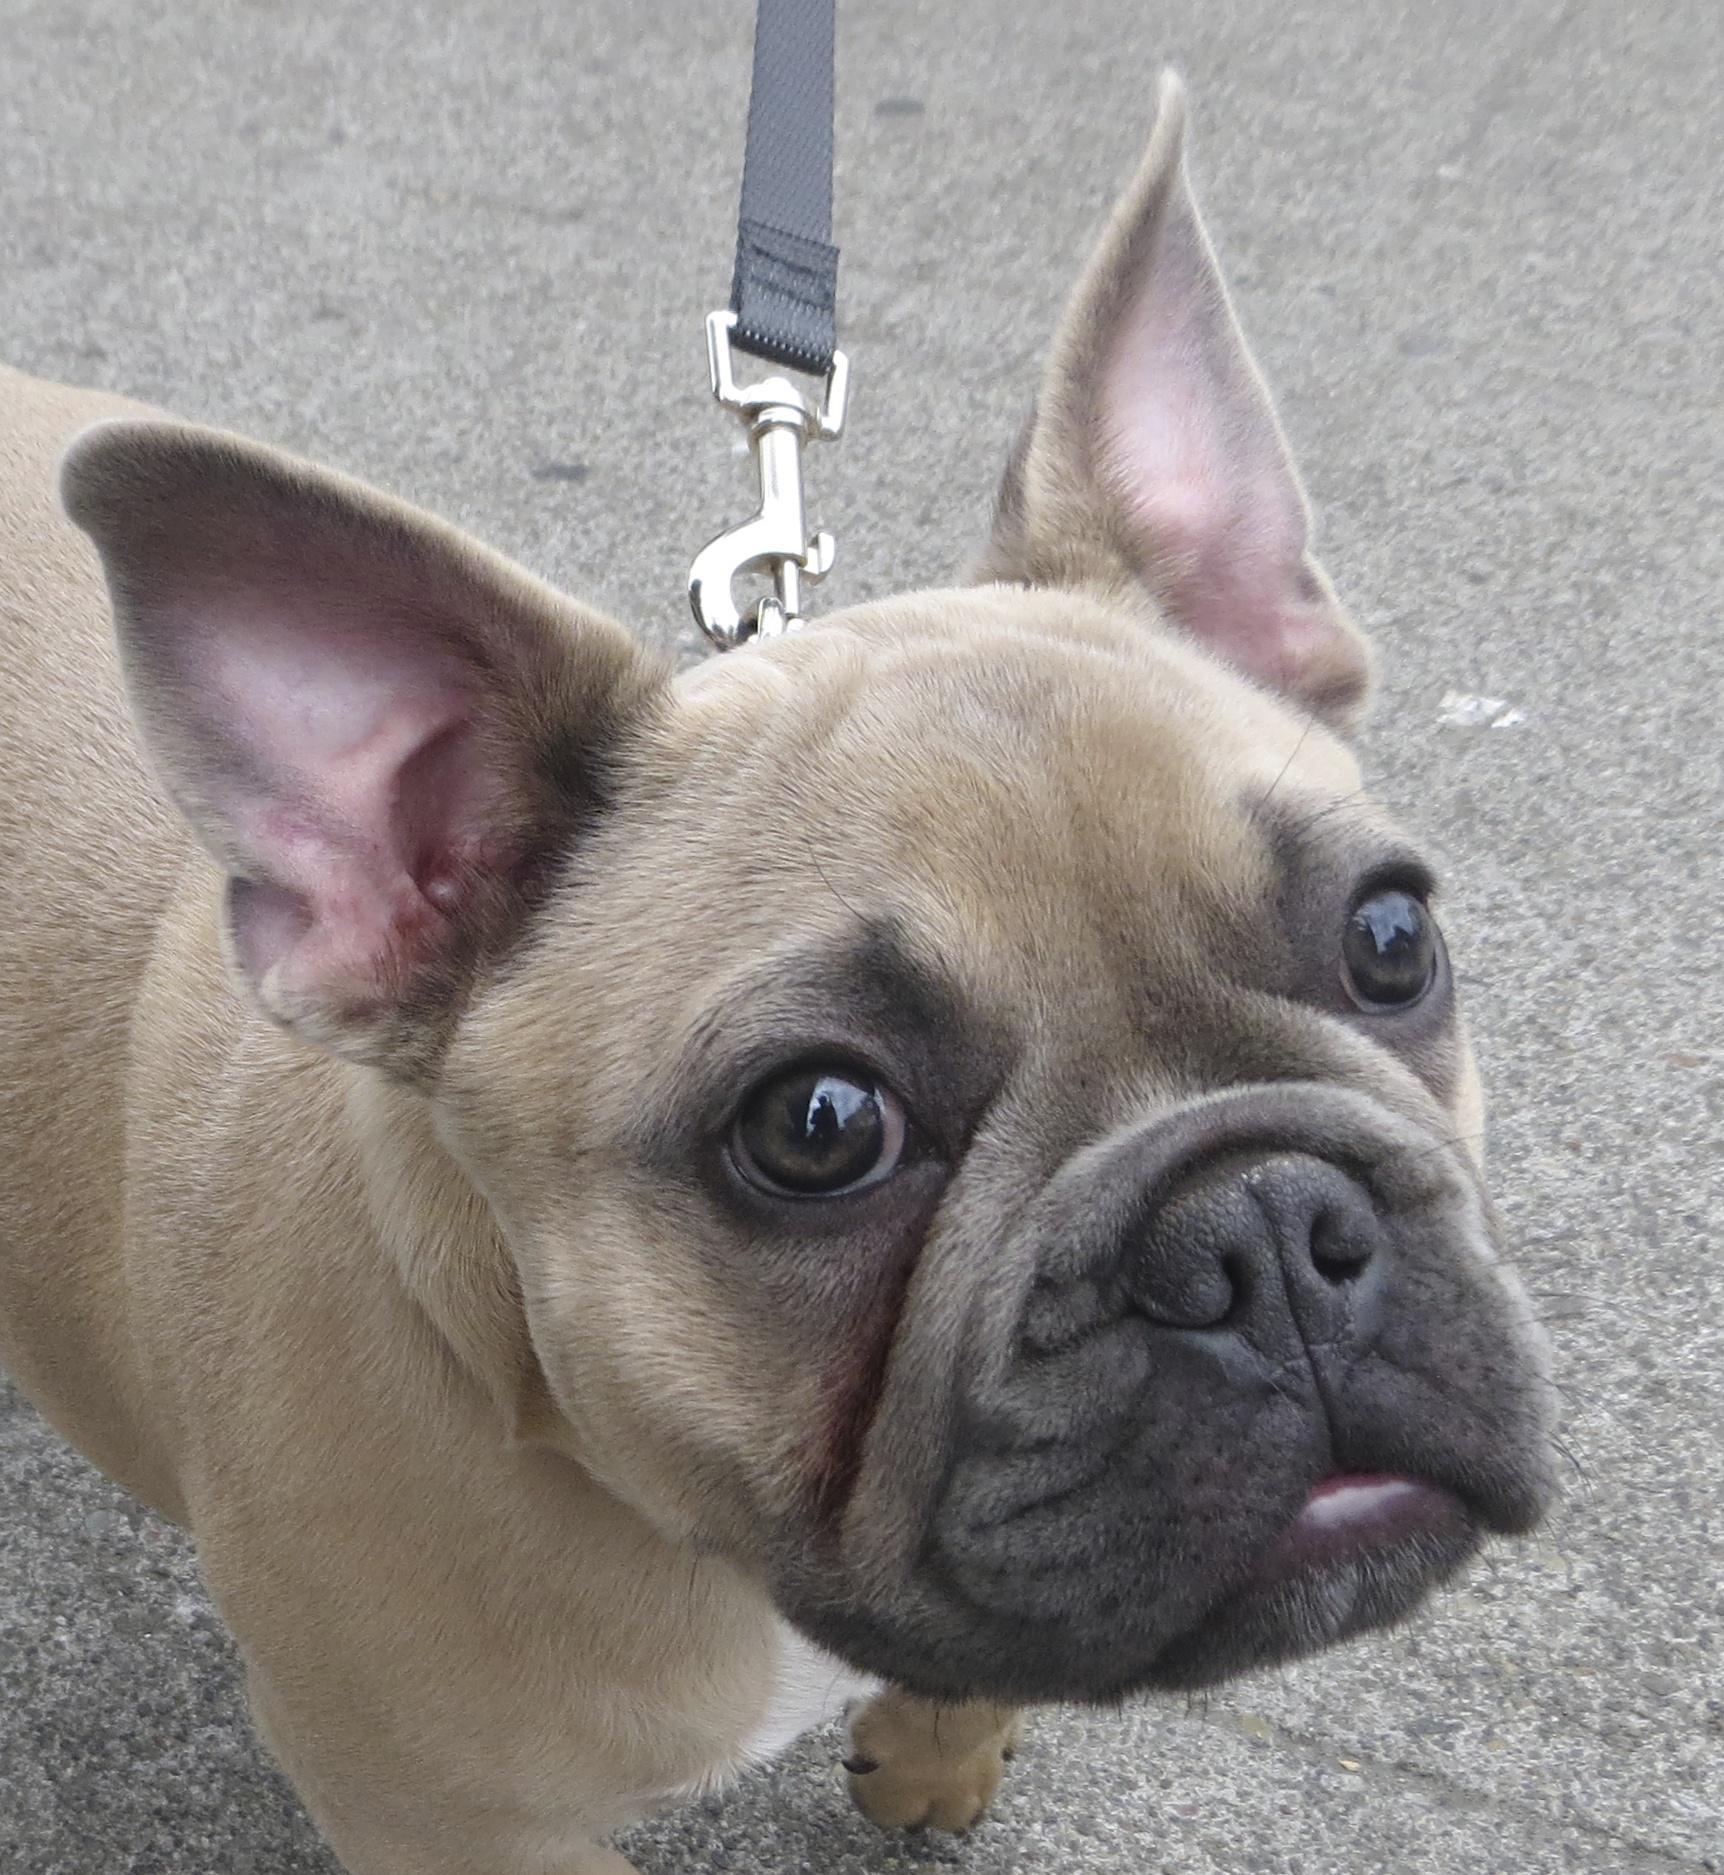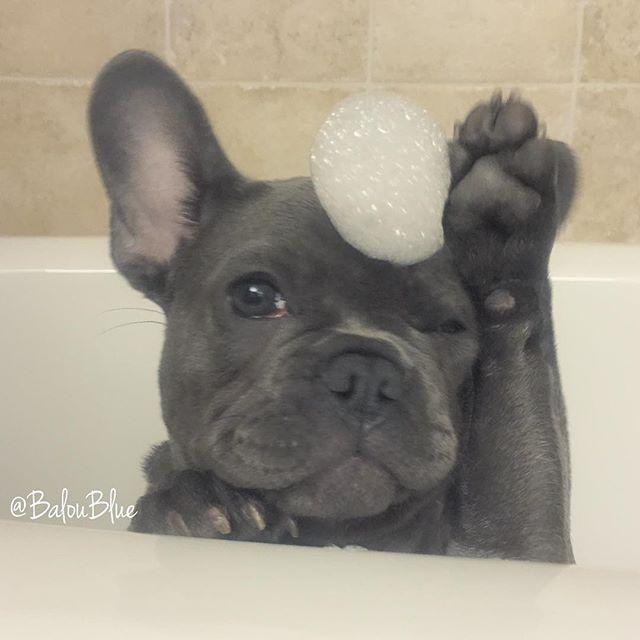The first image is the image on the left, the second image is the image on the right. Assess this claim about the two images: "Left image features one sitting puppy with dark gray fur and a white chest marking.". Correct or not? Answer yes or no. No. 